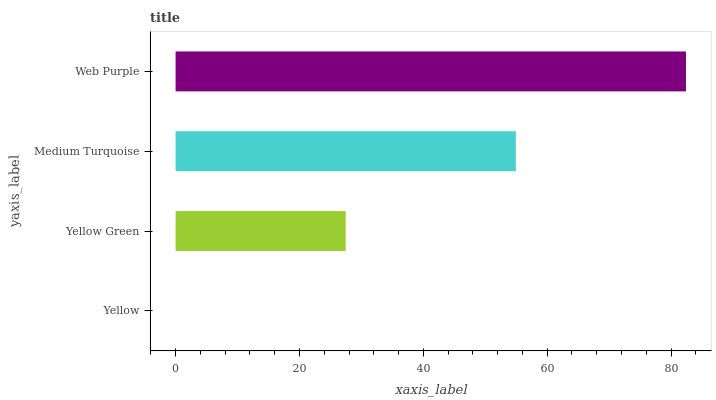Is Yellow the minimum?
Answer yes or no. Yes. Is Web Purple the maximum?
Answer yes or no. Yes. Is Yellow Green the minimum?
Answer yes or no. No. Is Yellow Green the maximum?
Answer yes or no. No. Is Yellow Green greater than Yellow?
Answer yes or no. Yes. Is Yellow less than Yellow Green?
Answer yes or no. Yes. Is Yellow greater than Yellow Green?
Answer yes or no. No. Is Yellow Green less than Yellow?
Answer yes or no. No. Is Medium Turquoise the high median?
Answer yes or no. Yes. Is Yellow Green the low median?
Answer yes or no. Yes. Is Yellow Green the high median?
Answer yes or no. No. Is Yellow the low median?
Answer yes or no. No. 